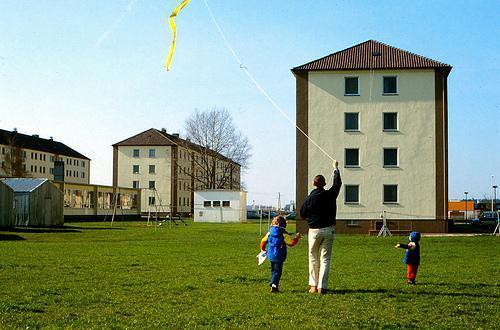How many people are in the photo?
Give a very brief answer. 3. How many tall buildings are there?
Give a very brief answer. 3. How many people are wearing red pants?
Give a very brief answer. 1. 